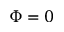Convert formula to latex. <formula><loc_0><loc_0><loc_500><loc_500>\Phi = 0</formula> 